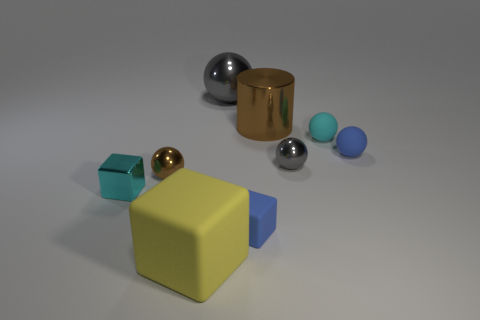Is the cylinder made of the same material as the large thing behind the large shiny cylinder?
Give a very brief answer. Yes. Is the number of tiny metal blocks less than the number of large things?
Your answer should be very brief. Yes. Are there any other things of the same color as the small metal block?
Your answer should be compact. Yes. There is a small cyan object that is made of the same material as the brown ball; what shape is it?
Your answer should be very brief. Cube. What number of blue matte cubes are right of the large shiny thing that is in front of the gray shiny sphere that is on the left side of the small blue cube?
Offer a very short reply. 0. There is a object that is behind the small gray thing and left of the brown metal cylinder; what shape is it?
Keep it short and to the point. Sphere. Is the number of small objects that are in front of the big cube less than the number of big gray metal blocks?
Provide a succinct answer. No. How many big things are either cylinders or metal blocks?
Your response must be concise. 1. The yellow rubber object is what size?
Offer a very short reply. Large. There is a tiny blue cube; how many small cyan things are in front of it?
Make the answer very short. 0. 